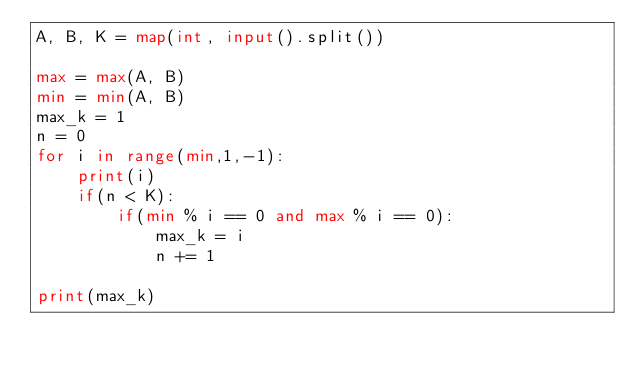<code> <loc_0><loc_0><loc_500><loc_500><_Python_>A, B, K = map(int, input().split())

max = max(A, B)
min = min(A, B)
max_k = 1
n = 0
for i in range(min,1,-1):
    print(i)
    if(n < K):
        if(min % i == 0 and max % i == 0):
            max_k = i
            n += 1

print(max_k)





</code> 